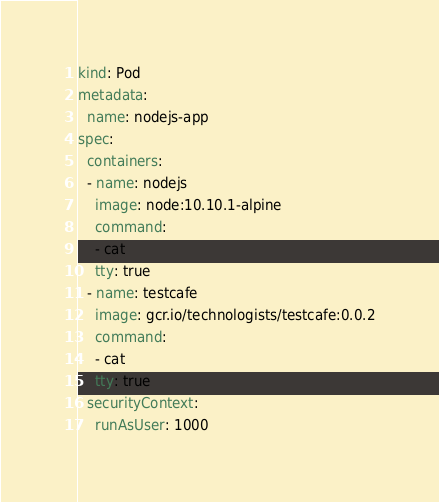<code> <loc_0><loc_0><loc_500><loc_500><_YAML_>kind: Pod
metadata:
  name: nodejs-app
spec:
  containers:
  - name: nodejs
    image: node:10.10.1-alpine
    command:
    - cat
    tty: true
  - name: testcafe
    image: gcr.io/technologists/testcafe:0.0.2
    command:
    - cat
    tty: true
  securityContext:
    runAsUser: 1000
</code> 